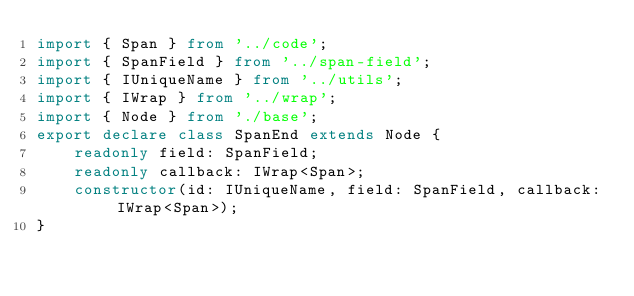Convert code to text. <code><loc_0><loc_0><loc_500><loc_500><_TypeScript_>import { Span } from '../code';
import { SpanField } from '../span-field';
import { IUniqueName } from '../utils';
import { IWrap } from '../wrap';
import { Node } from './base';
export declare class SpanEnd extends Node {
    readonly field: SpanField;
    readonly callback: IWrap<Span>;
    constructor(id: IUniqueName, field: SpanField, callback: IWrap<Span>);
}
</code> 